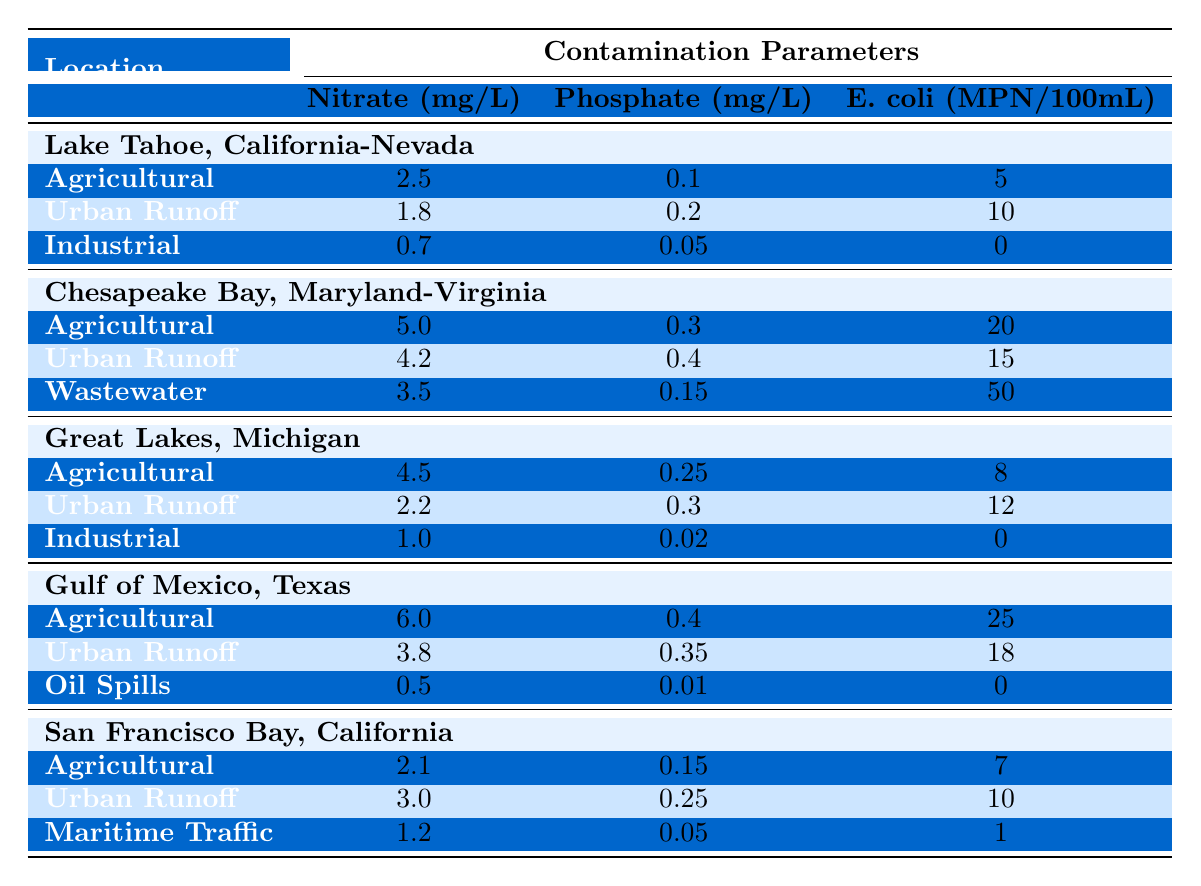What is the nitrate concentration in agricultural runoff at Lake Tahoe? The table indicates that the nitrate concentration for agricultural runoff at Lake Tahoe is listed under the section for that site, which shows a value of 2.5 mg/L.
Answer: 2.5 mg/L Which site has the highest E. coli count from wastewater? From the table, Chesapeake Bay has the highest E. coli count from wastewater, which is 50 MPN/100mL.
Answer: 50 MPN/100mL What is the phosphate concentration in urban runoff for the Great Lakes? The value for phosphate concentration in urban runoff for the Great Lakes is provided in the table as 0.3 mg/L.
Answer: 0.3 mg/L Which location has the lowest nitrate concentration in industrial contamination sources? A comparison of the nitrate concentrations in industrial sources shows that the lowest concentration is found at Lake Tahoe with a value of 0.7 mg/L.
Answer: 0.7 mg/L What is the average nitrate concentration in agricultural runoff across all locations? The average can be calculated by adding the nitrate values (2.5 + 5.0 + 4.5 + 6.0 + 2.1) = 20.1 mg/L and dividing by the number of locations (5). Thus, 20.1 / 5 = 4.02 mg/L.
Answer: 4.02 mg/L Is urban runoff the major source of E. coli contamination in the Gulf of Mexico? By comparing the E. coli values, urban runoff has 18 MPN/100mL, which is lower than the agricultural source at 25 MPN/100mL. Therefore, urban runoff is not the major source.
Answer: No How does the nitrate concentration of the Gulf of Mexico's agricultural runoff compare to that of Chesapeake Bay's agricultural runoff? The Gulf of Mexico has a nitrate concentration of 6.0 mg/L, which is higher than Chesapeake Bay's concentration of 5.0 mg/L. This shows that the Gulf of Mexico contributes more nitrate from agricultural runoff.
Answer: 6.0 mg/L is higher than 5.0 mg/L What is the total E. coli count from all contamination sources at San Francisco Bay? To find the total E. coli count, add values from all sources: 7 (agricultural) + 10 (urban runoff) + 1 (maritime traffic) = 18 MPN/100mL.
Answer: 18 MPN/100mL Which contamination source has the highest phosphate concentration in Chesapeake Bay? Reviewing the table, the wastewater contamination source has the highest phosphate concentration of 0.15 mg/L, higher than both agricultural and urban runoff.
Answer: Wastewater What would be the difference in E. coli counts between agricultural runoff from the Gulf of Mexico and that from the Great Lakes? The E. coli count for the Gulf of Mexico's agricultural runoff is 25 MPN/100mL, while for the Great Lakes it is 8 MPN/100mL. Subtracting gives 25 - 8 = 17 MPN/100mL.
Answer: 17 MPN/100mL 